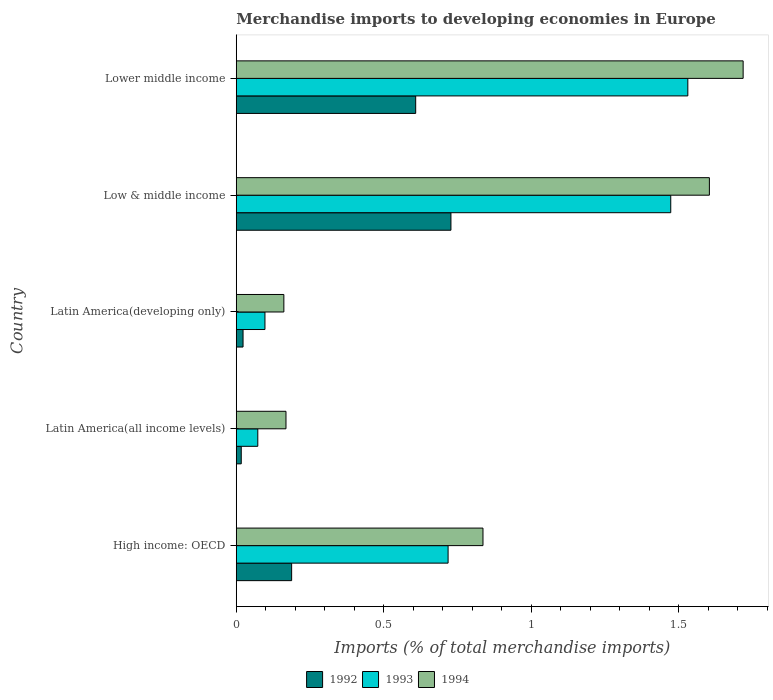How many different coloured bars are there?
Your answer should be compact. 3. Are the number of bars per tick equal to the number of legend labels?
Your response must be concise. Yes. Are the number of bars on each tick of the Y-axis equal?
Your response must be concise. Yes. How many bars are there on the 4th tick from the bottom?
Your response must be concise. 3. What is the label of the 1st group of bars from the top?
Ensure brevity in your answer.  Lower middle income. What is the percentage total merchandise imports in 1993 in Lower middle income?
Provide a short and direct response. 1.53. Across all countries, what is the maximum percentage total merchandise imports in 1993?
Your response must be concise. 1.53. Across all countries, what is the minimum percentage total merchandise imports in 1993?
Keep it short and to the point. 0.07. In which country was the percentage total merchandise imports in 1992 maximum?
Give a very brief answer. Low & middle income. In which country was the percentage total merchandise imports in 1994 minimum?
Give a very brief answer. Latin America(developing only). What is the total percentage total merchandise imports in 1994 in the graph?
Provide a succinct answer. 4.49. What is the difference between the percentage total merchandise imports in 1994 in High income: OECD and that in Lower middle income?
Offer a terse response. -0.88. What is the difference between the percentage total merchandise imports in 1993 in High income: OECD and the percentage total merchandise imports in 1994 in Latin America(developing only)?
Keep it short and to the point. 0.56. What is the average percentage total merchandise imports in 1994 per country?
Provide a short and direct response. 0.9. What is the difference between the percentage total merchandise imports in 1993 and percentage total merchandise imports in 1994 in Low & middle income?
Ensure brevity in your answer.  -0.13. What is the ratio of the percentage total merchandise imports in 1992 in Latin America(all income levels) to that in Latin America(developing only)?
Ensure brevity in your answer.  0.73. Is the percentage total merchandise imports in 1992 in High income: OECD less than that in Lower middle income?
Your response must be concise. Yes. Is the difference between the percentage total merchandise imports in 1993 in Latin America(all income levels) and Latin America(developing only) greater than the difference between the percentage total merchandise imports in 1994 in Latin America(all income levels) and Latin America(developing only)?
Offer a very short reply. No. What is the difference between the highest and the second highest percentage total merchandise imports in 1993?
Your response must be concise. 0.06. What is the difference between the highest and the lowest percentage total merchandise imports in 1993?
Offer a very short reply. 1.46. In how many countries, is the percentage total merchandise imports in 1994 greater than the average percentage total merchandise imports in 1994 taken over all countries?
Your answer should be very brief. 2. Is the sum of the percentage total merchandise imports in 1993 in Latin America(all income levels) and Low & middle income greater than the maximum percentage total merchandise imports in 1992 across all countries?
Provide a succinct answer. Yes. What does the 2nd bar from the bottom in Latin America(all income levels) represents?
Offer a very short reply. 1993. Is it the case that in every country, the sum of the percentage total merchandise imports in 1993 and percentage total merchandise imports in 1992 is greater than the percentage total merchandise imports in 1994?
Ensure brevity in your answer.  No. How many bars are there?
Your answer should be compact. 15. Are all the bars in the graph horizontal?
Make the answer very short. Yes. What is the difference between two consecutive major ticks on the X-axis?
Ensure brevity in your answer.  0.5. Are the values on the major ticks of X-axis written in scientific E-notation?
Offer a terse response. No. Does the graph contain any zero values?
Offer a terse response. No. How are the legend labels stacked?
Offer a very short reply. Horizontal. What is the title of the graph?
Ensure brevity in your answer.  Merchandise imports to developing economies in Europe. What is the label or title of the X-axis?
Give a very brief answer. Imports (% of total merchandise imports). What is the label or title of the Y-axis?
Your response must be concise. Country. What is the Imports (% of total merchandise imports) of 1992 in High income: OECD?
Provide a succinct answer. 0.19. What is the Imports (% of total merchandise imports) in 1993 in High income: OECD?
Provide a succinct answer. 0.72. What is the Imports (% of total merchandise imports) of 1994 in High income: OECD?
Offer a very short reply. 0.84. What is the Imports (% of total merchandise imports) in 1992 in Latin America(all income levels)?
Give a very brief answer. 0.02. What is the Imports (% of total merchandise imports) in 1993 in Latin America(all income levels)?
Offer a very short reply. 0.07. What is the Imports (% of total merchandise imports) in 1994 in Latin America(all income levels)?
Your answer should be compact. 0.17. What is the Imports (% of total merchandise imports) of 1992 in Latin America(developing only)?
Provide a short and direct response. 0.02. What is the Imports (% of total merchandise imports) in 1993 in Latin America(developing only)?
Keep it short and to the point. 0.1. What is the Imports (% of total merchandise imports) of 1994 in Latin America(developing only)?
Your answer should be very brief. 0.16. What is the Imports (% of total merchandise imports) in 1992 in Low & middle income?
Your answer should be very brief. 0.73. What is the Imports (% of total merchandise imports) of 1993 in Low & middle income?
Provide a succinct answer. 1.47. What is the Imports (% of total merchandise imports) in 1994 in Low & middle income?
Offer a very short reply. 1.6. What is the Imports (% of total merchandise imports) in 1992 in Lower middle income?
Offer a very short reply. 0.61. What is the Imports (% of total merchandise imports) in 1993 in Lower middle income?
Your answer should be very brief. 1.53. What is the Imports (% of total merchandise imports) in 1994 in Lower middle income?
Give a very brief answer. 1.72. Across all countries, what is the maximum Imports (% of total merchandise imports) of 1992?
Ensure brevity in your answer.  0.73. Across all countries, what is the maximum Imports (% of total merchandise imports) of 1993?
Your answer should be very brief. 1.53. Across all countries, what is the maximum Imports (% of total merchandise imports) in 1994?
Provide a short and direct response. 1.72. Across all countries, what is the minimum Imports (% of total merchandise imports) of 1992?
Offer a terse response. 0.02. Across all countries, what is the minimum Imports (% of total merchandise imports) in 1993?
Keep it short and to the point. 0.07. Across all countries, what is the minimum Imports (% of total merchandise imports) in 1994?
Provide a succinct answer. 0.16. What is the total Imports (% of total merchandise imports) of 1992 in the graph?
Your response must be concise. 1.56. What is the total Imports (% of total merchandise imports) of 1993 in the graph?
Your answer should be very brief. 3.89. What is the total Imports (% of total merchandise imports) in 1994 in the graph?
Offer a very short reply. 4.49. What is the difference between the Imports (% of total merchandise imports) of 1992 in High income: OECD and that in Latin America(all income levels)?
Provide a succinct answer. 0.17. What is the difference between the Imports (% of total merchandise imports) in 1993 in High income: OECD and that in Latin America(all income levels)?
Keep it short and to the point. 0.65. What is the difference between the Imports (% of total merchandise imports) of 1994 in High income: OECD and that in Latin America(all income levels)?
Ensure brevity in your answer.  0.67. What is the difference between the Imports (% of total merchandise imports) of 1992 in High income: OECD and that in Latin America(developing only)?
Ensure brevity in your answer.  0.16. What is the difference between the Imports (% of total merchandise imports) in 1993 in High income: OECD and that in Latin America(developing only)?
Your answer should be very brief. 0.62. What is the difference between the Imports (% of total merchandise imports) of 1994 in High income: OECD and that in Latin America(developing only)?
Keep it short and to the point. 0.67. What is the difference between the Imports (% of total merchandise imports) of 1992 in High income: OECD and that in Low & middle income?
Your response must be concise. -0.54. What is the difference between the Imports (% of total merchandise imports) in 1993 in High income: OECD and that in Low & middle income?
Offer a terse response. -0.75. What is the difference between the Imports (% of total merchandise imports) of 1994 in High income: OECD and that in Low & middle income?
Offer a very short reply. -0.77. What is the difference between the Imports (% of total merchandise imports) in 1992 in High income: OECD and that in Lower middle income?
Offer a terse response. -0.42. What is the difference between the Imports (% of total merchandise imports) in 1993 in High income: OECD and that in Lower middle income?
Your answer should be compact. -0.81. What is the difference between the Imports (% of total merchandise imports) in 1994 in High income: OECD and that in Lower middle income?
Your answer should be very brief. -0.88. What is the difference between the Imports (% of total merchandise imports) in 1992 in Latin America(all income levels) and that in Latin America(developing only)?
Your response must be concise. -0.01. What is the difference between the Imports (% of total merchandise imports) of 1993 in Latin America(all income levels) and that in Latin America(developing only)?
Give a very brief answer. -0.02. What is the difference between the Imports (% of total merchandise imports) of 1994 in Latin America(all income levels) and that in Latin America(developing only)?
Your response must be concise. 0.01. What is the difference between the Imports (% of total merchandise imports) of 1992 in Latin America(all income levels) and that in Low & middle income?
Provide a succinct answer. -0.71. What is the difference between the Imports (% of total merchandise imports) of 1993 in Latin America(all income levels) and that in Low & middle income?
Your answer should be compact. -1.4. What is the difference between the Imports (% of total merchandise imports) of 1994 in Latin America(all income levels) and that in Low & middle income?
Your response must be concise. -1.44. What is the difference between the Imports (% of total merchandise imports) in 1992 in Latin America(all income levels) and that in Lower middle income?
Provide a short and direct response. -0.59. What is the difference between the Imports (% of total merchandise imports) in 1993 in Latin America(all income levels) and that in Lower middle income?
Your answer should be very brief. -1.46. What is the difference between the Imports (% of total merchandise imports) in 1994 in Latin America(all income levels) and that in Lower middle income?
Keep it short and to the point. -1.55. What is the difference between the Imports (% of total merchandise imports) of 1992 in Latin America(developing only) and that in Low & middle income?
Keep it short and to the point. -0.7. What is the difference between the Imports (% of total merchandise imports) in 1993 in Latin America(developing only) and that in Low & middle income?
Your response must be concise. -1.38. What is the difference between the Imports (% of total merchandise imports) in 1994 in Latin America(developing only) and that in Low & middle income?
Your answer should be compact. -1.44. What is the difference between the Imports (% of total merchandise imports) in 1992 in Latin America(developing only) and that in Lower middle income?
Your answer should be very brief. -0.59. What is the difference between the Imports (% of total merchandise imports) in 1993 in Latin America(developing only) and that in Lower middle income?
Give a very brief answer. -1.43. What is the difference between the Imports (% of total merchandise imports) of 1994 in Latin America(developing only) and that in Lower middle income?
Provide a succinct answer. -1.56. What is the difference between the Imports (% of total merchandise imports) of 1992 in Low & middle income and that in Lower middle income?
Ensure brevity in your answer.  0.12. What is the difference between the Imports (% of total merchandise imports) in 1993 in Low & middle income and that in Lower middle income?
Offer a very short reply. -0.06. What is the difference between the Imports (% of total merchandise imports) of 1994 in Low & middle income and that in Lower middle income?
Provide a succinct answer. -0.11. What is the difference between the Imports (% of total merchandise imports) of 1992 in High income: OECD and the Imports (% of total merchandise imports) of 1993 in Latin America(all income levels)?
Provide a succinct answer. 0.11. What is the difference between the Imports (% of total merchandise imports) of 1992 in High income: OECD and the Imports (% of total merchandise imports) of 1994 in Latin America(all income levels)?
Provide a succinct answer. 0.02. What is the difference between the Imports (% of total merchandise imports) of 1993 in High income: OECD and the Imports (% of total merchandise imports) of 1994 in Latin America(all income levels)?
Give a very brief answer. 0.55. What is the difference between the Imports (% of total merchandise imports) of 1992 in High income: OECD and the Imports (% of total merchandise imports) of 1993 in Latin America(developing only)?
Keep it short and to the point. 0.09. What is the difference between the Imports (% of total merchandise imports) of 1992 in High income: OECD and the Imports (% of total merchandise imports) of 1994 in Latin America(developing only)?
Your answer should be compact. 0.03. What is the difference between the Imports (% of total merchandise imports) in 1993 in High income: OECD and the Imports (% of total merchandise imports) in 1994 in Latin America(developing only)?
Ensure brevity in your answer.  0.56. What is the difference between the Imports (% of total merchandise imports) of 1992 in High income: OECD and the Imports (% of total merchandise imports) of 1993 in Low & middle income?
Offer a terse response. -1.28. What is the difference between the Imports (% of total merchandise imports) of 1992 in High income: OECD and the Imports (% of total merchandise imports) of 1994 in Low & middle income?
Your answer should be very brief. -1.42. What is the difference between the Imports (% of total merchandise imports) of 1993 in High income: OECD and the Imports (% of total merchandise imports) of 1994 in Low & middle income?
Provide a short and direct response. -0.89. What is the difference between the Imports (% of total merchandise imports) in 1992 in High income: OECD and the Imports (% of total merchandise imports) in 1993 in Lower middle income?
Your answer should be compact. -1.34. What is the difference between the Imports (% of total merchandise imports) of 1992 in High income: OECD and the Imports (% of total merchandise imports) of 1994 in Lower middle income?
Your answer should be very brief. -1.53. What is the difference between the Imports (% of total merchandise imports) of 1993 in High income: OECD and the Imports (% of total merchandise imports) of 1994 in Lower middle income?
Your answer should be very brief. -1. What is the difference between the Imports (% of total merchandise imports) of 1992 in Latin America(all income levels) and the Imports (% of total merchandise imports) of 1993 in Latin America(developing only)?
Ensure brevity in your answer.  -0.08. What is the difference between the Imports (% of total merchandise imports) in 1992 in Latin America(all income levels) and the Imports (% of total merchandise imports) in 1994 in Latin America(developing only)?
Ensure brevity in your answer.  -0.14. What is the difference between the Imports (% of total merchandise imports) of 1993 in Latin America(all income levels) and the Imports (% of total merchandise imports) of 1994 in Latin America(developing only)?
Your answer should be very brief. -0.09. What is the difference between the Imports (% of total merchandise imports) of 1992 in Latin America(all income levels) and the Imports (% of total merchandise imports) of 1993 in Low & middle income?
Offer a very short reply. -1.46. What is the difference between the Imports (% of total merchandise imports) in 1992 in Latin America(all income levels) and the Imports (% of total merchandise imports) in 1994 in Low & middle income?
Ensure brevity in your answer.  -1.59. What is the difference between the Imports (% of total merchandise imports) of 1993 in Latin America(all income levels) and the Imports (% of total merchandise imports) of 1994 in Low & middle income?
Offer a terse response. -1.53. What is the difference between the Imports (% of total merchandise imports) of 1992 in Latin America(all income levels) and the Imports (% of total merchandise imports) of 1993 in Lower middle income?
Your answer should be compact. -1.51. What is the difference between the Imports (% of total merchandise imports) in 1992 in Latin America(all income levels) and the Imports (% of total merchandise imports) in 1994 in Lower middle income?
Give a very brief answer. -1.7. What is the difference between the Imports (% of total merchandise imports) in 1993 in Latin America(all income levels) and the Imports (% of total merchandise imports) in 1994 in Lower middle income?
Provide a short and direct response. -1.65. What is the difference between the Imports (% of total merchandise imports) in 1992 in Latin America(developing only) and the Imports (% of total merchandise imports) in 1993 in Low & middle income?
Make the answer very short. -1.45. What is the difference between the Imports (% of total merchandise imports) in 1992 in Latin America(developing only) and the Imports (% of total merchandise imports) in 1994 in Low & middle income?
Make the answer very short. -1.58. What is the difference between the Imports (% of total merchandise imports) of 1993 in Latin America(developing only) and the Imports (% of total merchandise imports) of 1994 in Low & middle income?
Provide a succinct answer. -1.51. What is the difference between the Imports (% of total merchandise imports) of 1992 in Latin America(developing only) and the Imports (% of total merchandise imports) of 1993 in Lower middle income?
Offer a terse response. -1.51. What is the difference between the Imports (% of total merchandise imports) of 1992 in Latin America(developing only) and the Imports (% of total merchandise imports) of 1994 in Lower middle income?
Make the answer very short. -1.7. What is the difference between the Imports (% of total merchandise imports) of 1993 in Latin America(developing only) and the Imports (% of total merchandise imports) of 1994 in Lower middle income?
Your answer should be compact. -1.62. What is the difference between the Imports (% of total merchandise imports) of 1992 in Low & middle income and the Imports (% of total merchandise imports) of 1993 in Lower middle income?
Offer a terse response. -0.8. What is the difference between the Imports (% of total merchandise imports) in 1992 in Low & middle income and the Imports (% of total merchandise imports) in 1994 in Lower middle income?
Your response must be concise. -0.99. What is the difference between the Imports (% of total merchandise imports) of 1993 in Low & middle income and the Imports (% of total merchandise imports) of 1994 in Lower middle income?
Provide a short and direct response. -0.25. What is the average Imports (% of total merchandise imports) of 1992 per country?
Offer a terse response. 0.31. What is the average Imports (% of total merchandise imports) of 1993 per country?
Provide a short and direct response. 0.78. What is the average Imports (% of total merchandise imports) in 1994 per country?
Make the answer very short. 0.9. What is the difference between the Imports (% of total merchandise imports) in 1992 and Imports (% of total merchandise imports) in 1993 in High income: OECD?
Offer a very short reply. -0.53. What is the difference between the Imports (% of total merchandise imports) in 1992 and Imports (% of total merchandise imports) in 1994 in High income: OECD?
Keep it short and to the point. -0.65. What is the difference between the Imports (% of total merchandise imports) of 1993 and Imports (% of total merchandise imports) of 1994 in High income: OECD?
Provide a succinct answer. -0.12. What is the difference between the Imports (% of total merchandise imports) in 1992 and Imports (% of total merchandise imports) in 1993 in Latin America(all income levels)?
Offer a very short reply. -0.06. What is the difference between the Imports (% of total merchandise imports) of 1992 and Imports (% of total merchandise imports) of 1994 in Latin America(all income levels)?
Your answer should be very brief. -0.15. What is the difference between the Imports (% of total merchandise imports) of 1993 and Imports (% of total merchandise imports) of 1994 in Latin America(all income levels)?
Provide a succinct answer. -0.1. What is the difference between the Imports (% of total merchandise imports) of 1992 and Imports (% of total merchandise imports) of 1993 in Latin America(developing only)?
Offer a terse response. -0.07. What is the difference between the Imports (% of total merchandise imports) of 1992 and Imports (% of total merchandise imports) of 1994 in Latin America(developing only)?
Provide a short and direct response. -0.14. What is the difference between the Imports (% of total merchandise imports) of 1993 and Imports (% of total merchandise imports) of 1994 in Latin America(developing only)?
Offer a terse response. -0.06. What is the difference between the Imports (% of total merchandise imports) of 1992 and Imports (% of total merchandise imports) of 1993 in Low & middle income?
Your answer should be very brief. -0.74. What is the difference between the Imports (% of total merchandise imports) of 1992 and Imports (% of total merchandise imports) of 1994 in Low & middle income?
Your response must be concise. -0.88. What is the difference between the Imports (% of total merchandise imports) of 1993 and Imports (% of total merchandise imports) of 1994 in Low & middle income?
Your answer should be compact. -0.13. What is the difference between the Imports (% of total merchandise imports) in 1992 and Imports (% of total merchandise imports) in 1993 in Lower middle income?
Provide a short and direct response. -0.92. What is the difference between the Imports (% of total merchandise imports) in 1992 and Imports (% of total merchandise imports) in 1994 in Lower middle income?
Provide a succinct answer. -1.11. What is the difference between the Imports (% of total merchandise imports) of 1993 and Imports (% of total merchandise imports) of 1994 in Lower middle income?
Keep it short and to the point. -0.19. What is the ratio of the Imports (% of total merchandise imports) of 1992 in High income: OECD to that in Latin America(all income levels)?
Your answer should be compact. 11.1. What is the ratio of the Imports (% of total merchandise imports) in 1993 in High income: OECD to that in Latin America(all income levels)?
Your response must be concise. 9.84. What is the ratio of the Imports (% of total merchandise imports) of 1994 in High income: OECD to that in Latin America(all income levels)?
Your answer should be very brief. 4.96. What is the ratio of the Imports (% of total merchandise imports) of 1992 in High income: OECD to that in Latin America(developing only)?
Keep it short and to the point. 8.15. What is the ratio of the Imports (% of total merchandise imports) in 1993 in High income: OECD to that in Latin America(developing only)?
Keep it short and to the point. 7.38. What is the ratio of the Imports (% of total merchandise imports) of 1994 in High income: OECD to that in Latin America(developing only)?
Ensure brevity in your answer.  5.18. What is the ratio of the Imports (% of total merchandise imports) of 1992 in High income: OECD to that in Low & middle income?
Ensure brevity in your answer.  0.26. What is the ratio of the Imports (% of total merchandise imports) in 1993 in High income: OECD to that in Low & middle income?
Provide a succinct answer. 0.49. What is the ratio of the Imports (% of total merchandise imports) in 1994 in High income: OECD to that in Low & middle income?
Offer a terse response. 0.52. What is the ratio of the Imports (% of total merchandise imports) of 1992 in High income: OECD to that in Lower middle income?
Your response must be concise. 0.31. What is the ratio of the Imports (% of total merchandise imports) in 1993 in High income: OECD to that in Lower middle income?
Keep it short and to the point. 0.47. What is the ratio of the Imports (% of total merchandise imports) of 1994 in High income: OECD to that in Lower middle income?
Offer a terse response. 0.49. What is the ratio of the Imports (% of total merchandise imports) of 1992 in Latin America(all income levels) to that in Latin America(developing only)?
Ensure brevity in your answer.  0.73. What is the ratio of the Imports (% of total merchandise imports) in 1993 in Latin America(all income levels) to that in Latin America(developing only)?
Keep it short and to the point. 0.75. What is the ratio of the Imports (% of total merchandise imports) in 1994 in Latin America(all income levels) to that in Latin America(developing only)?
Offer a very short reply. 1.04. What is the ratio of the Imports (% of total merchandise imports) in 1992 in Latin America(all income levels) to that in Low & middle income?
Offer a terse response. 0.02. What is the ratio of the Imports (% of total merchandise imports) in 1993 in Latin America(all income levels) to that in Low & middle income?
Make the answer very short. 0.05. What is the ratio of the Imports (% of total merchandise imports) of 1994 in Latin America(all income levels) to that in Low & middle income?
Offer a terse response. 0.11. What is the ratio of the Imports (% of total merchandise imports) of 1992 in Latin America(all income levels) to that in Lower middle income?
Make the answer very short. 0.03. What is the ratio of the Imports (% of total merchandise imports) in 1993 in Latin America(all income levels) to that in Lower middle income?
Offer a terse response. 0.05. What is the ratio of the Imports (% of total merchandise imports) of 1994 in Latin America(all income levels) to that in Lower middle income?
Provide a succinct answer. 0.1. What is the ratio of the Imports (% of total merchandise imports) of 1992 in Latin America(developing only) to that in Low & middle income?
Provide a succinct answer. 0.03. What is the ratio of the Imports (% of total merchandise imports) of 1993 in Latin America(developing only) to that in Low & middle income?
Keep it short and to the point. 0.07. What is the ratio of the Imports (% of total merchandise imports) of 1994 in Latin America(developing only) to that in Low & middle income?
Offer a terse response. 0.1. What is the ratio of the Imports (% of total merchandise imports) in 1992 in Latin America(developing only) to that in Lower middle income?
Provide a succinct answer. 0.04. What is the ratio of the Imports (% of total merchandise imports) in 1993 in Latin America(developing only) to that in Lower middle income?
Your answer should be compact. 0.06. What is the ratio of the Imports (% of total merchandise imports) in 1994 in Latin America(developing only) to that in Lower middle income?
Ensure brevity in your answer.  0.09. What is the ratio of the Imports (% of total merchandise imports) in 1992 in Low & middle income to that in Lower middle income?
Your answer should be very brief. 1.2. What is the ratio of the Imports (% of total merchandise imports) in 1993 in Low & middle income to that in Lower middle income?
Offer a very short reply. 0.96. What is the ratio of the Imports (% of total merchandise imports) of 1994 in Low & middle income to that in Lower middle income?
Your answer should be very brief. 0.93. What is the difference between the highest and the second highest Imports (% of total merchandise imports) of 1992?
Offer a terse response. 0.12. What is the difference between the highest and the second highest Imports (% of total merchandise imports) of 1993?
Ensure brevity in your answer.  0.06. What is the difference between the highest and the second highest Imports (% of total merchandise imports) in 1994?
Provide a short and direct response. 0.11. What is the difference between the highest and the lowest Imports (% of total merchandise imports) of 1992?
Your answer should be very brief. 0.71. What is the difference between the highest and the lowest Imports (% of total merchandise imports) of 1993?
Ensure brevity in your answer.  1.46. What is the difference between the highest and the lowest Imports (% of total merchandise imports) in 1994?
Ensure brevity in your answer.  1.56. 